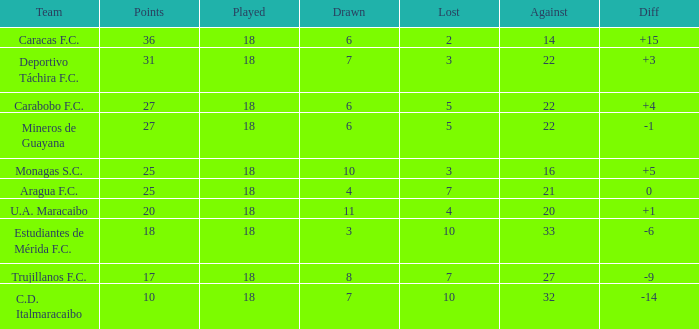What is the lowest number of points of any team with less than 6 draws and less than 18 matches played? None. 